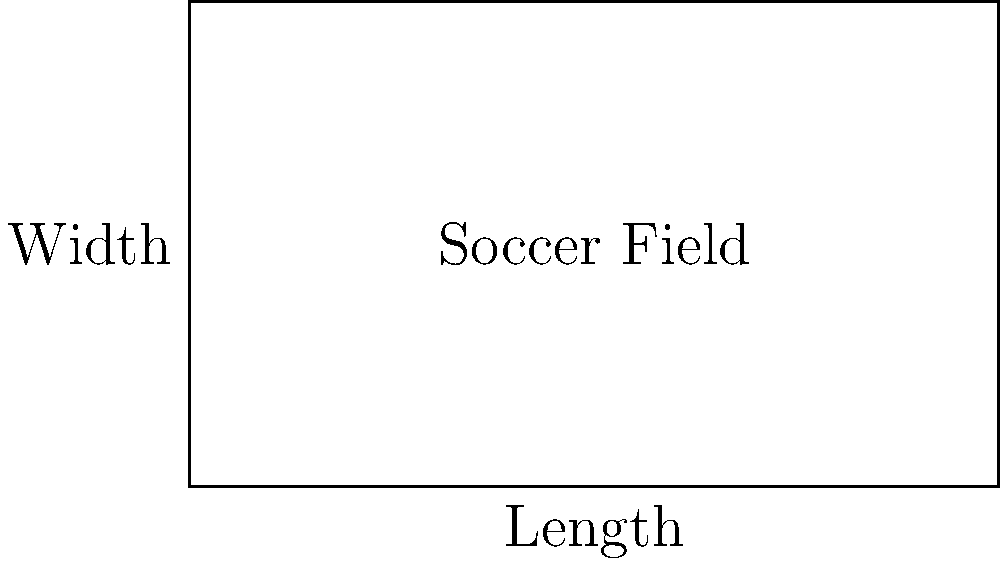As a sports bar owner, you're considering installing a miniature soccer field for customers to enjoy during halftime. If the total area of the field is 6000 square feet and the length-to-width ratio is 5:3, what are the dimensions of the field? Let's solve this step-by-step:

1) Let the width of the field be $w$ and the length be $l$.

2) Given the length-to-width ratio of 5:3, we can write:
   $\frac{l}{w} = \frac{5}{3}$
   
3) This means $l = \frac{5}{3}w$

4) We know that the area of a rectangle is length times width:
   $A = l \times w$

5) The total area is 6000 square feet, so:
   $6000 = l \times w$

6) Substituting $l = \frac{5}{3}w$ from step 3:
   $6000 = \frac{5}{3}w \times w = \frac{5}{3}w^2$

7) Solve for $w$:
   $w^2 = 6000 \times \frac{3}{5} = 3600$
   $w = \sqrt{3600} = 60$ feet

8) Now we can find $l$:
   $l = \frac{5}{3}w = \frac{5}{3} \times 60 = 100$ feet

Therefore, the dimensions of the field are 100 feet long and 60 feet wide.
Answer: 100 feet long, 60 feet wide 